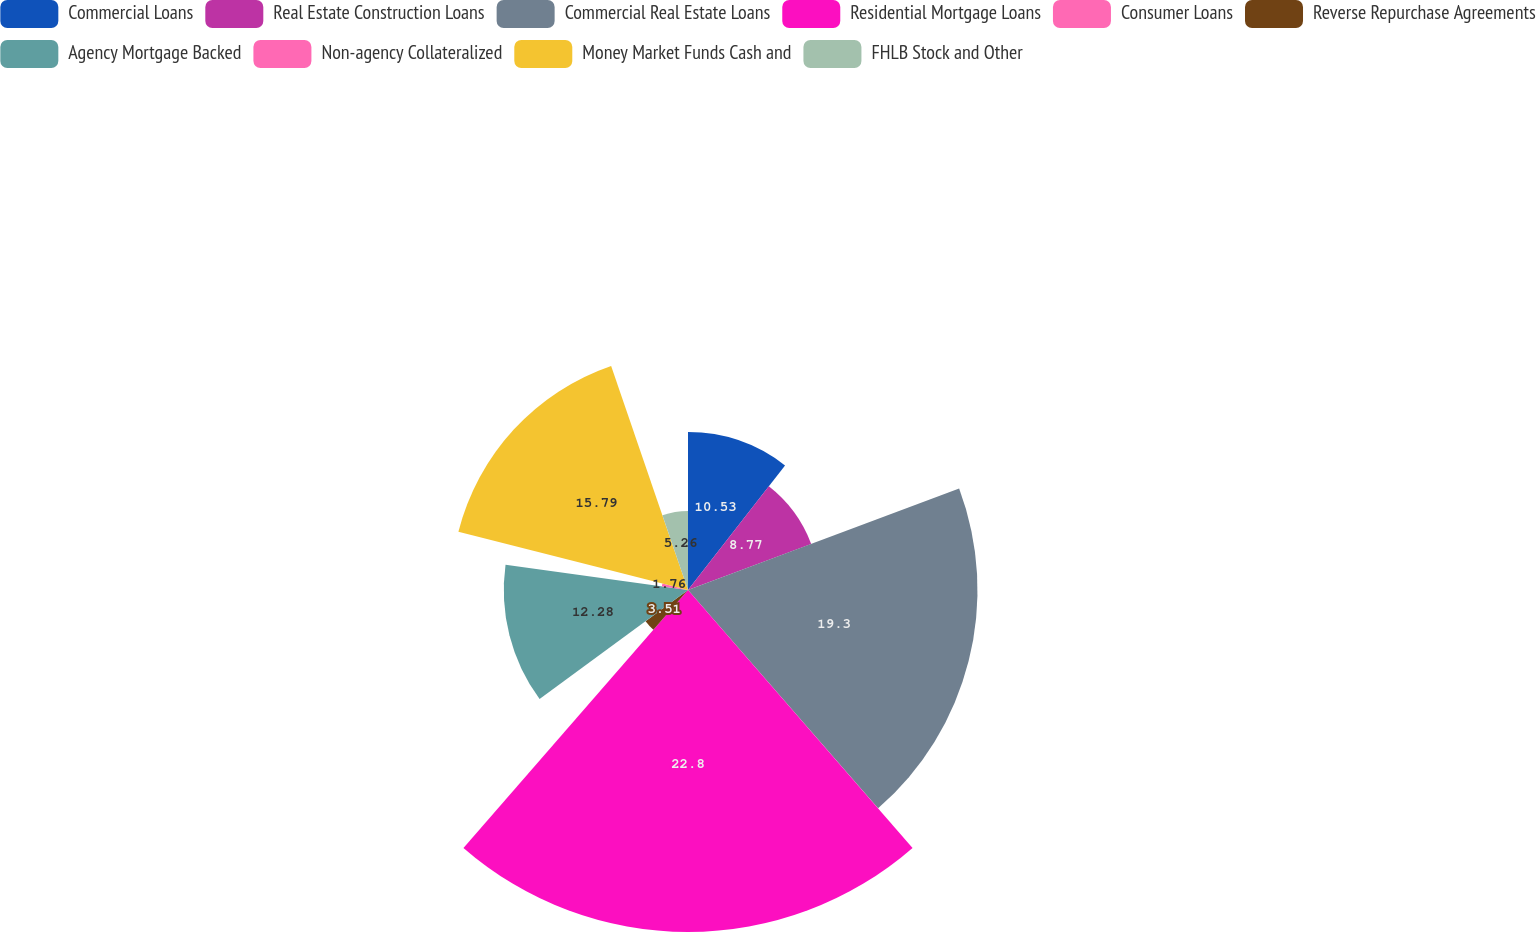Convert chart to OTSL. <chart><loc_0><loc_0><loc_500><loc_500><pie_chart><fcel>Commercial Loans<fcel>Real Estate Construction Loans<fcel>Commercial Real Estate Loans<fcel>Residential Mortgage Loans<fcel>Consumer Loans<fcel>Reverse Repurchase Agreements<fcel>Agency Mortgage Backed<fcel>Non-agency Collateralized<fcel>Money Market Funds Cash and<fcel>FHLB Stock and Other<nl><fcel>10.53%<fcel>8.77%<fcel>19.3%<fcel>22.8%<fcel>0.0%<fcel>3.51%<fcel>12.28%<fcel>1.76%<fcel>15.79%<fcel>5.26%<nl></chart> 